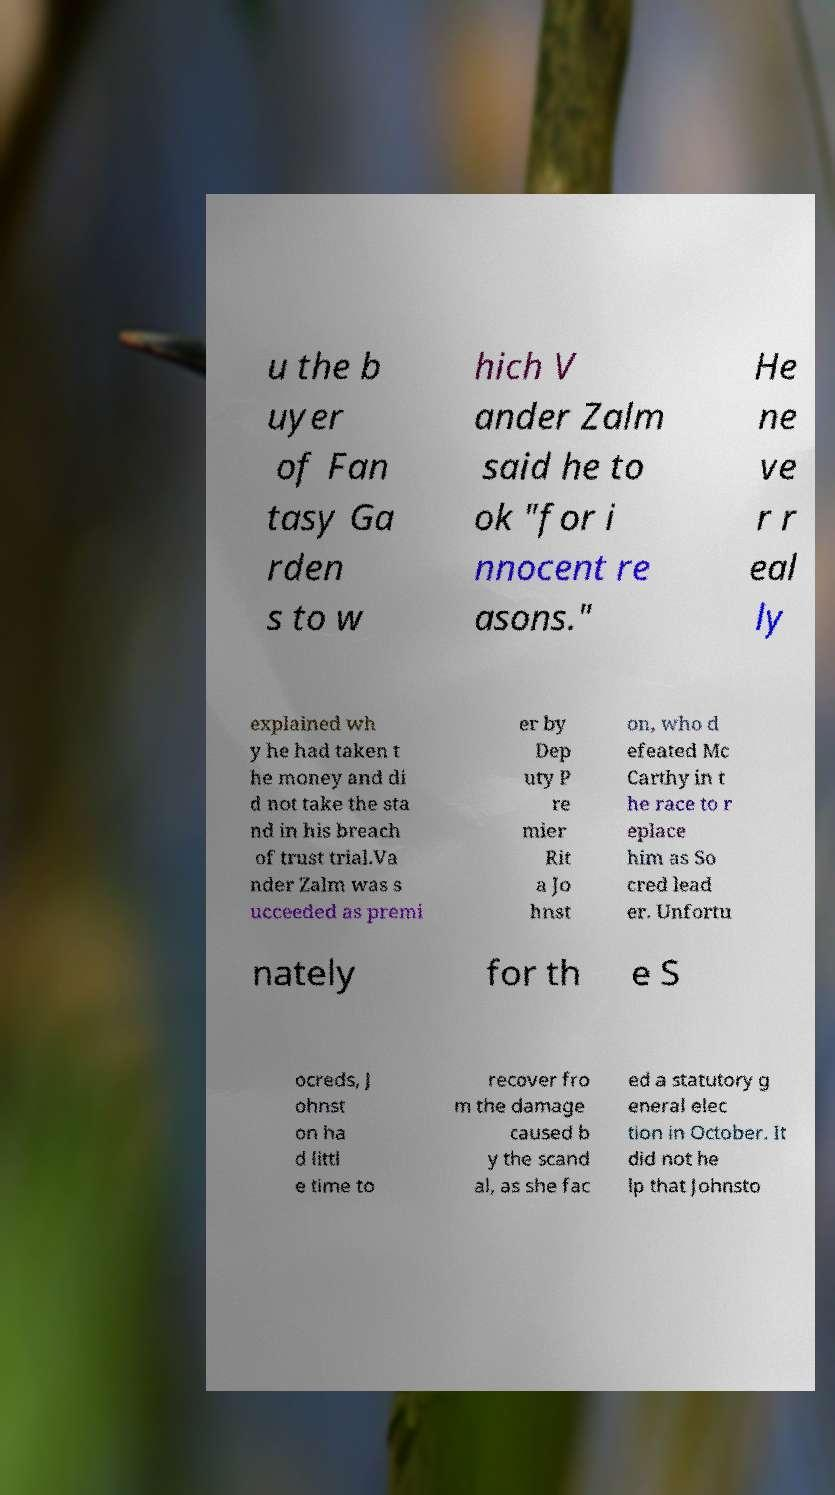Please read and relay the text visible in this image. What does it say? u the b uyer of Fan tasy Ga rden s to w hich V ander Zalm said he to ok "for i nnocent re asons." He ne ve r r eal ly explained wh y he had taken t he money and di d not take the sta nd in his breach of trust trial.Va nder Zalm was s ucceeded as premi er by Dep uty P re mier Rit a Jo hnst on, who d efeated Mc Carthy in t he race to r eplace him as So cred lead er. Unfortu nately for th e S ocreds, J ohnst on ha d littl e time to recover fro m the damage caused b y the scand al, as she fac ed a statutory g eneral elec tion in October. It did not he lp that Johnsto 